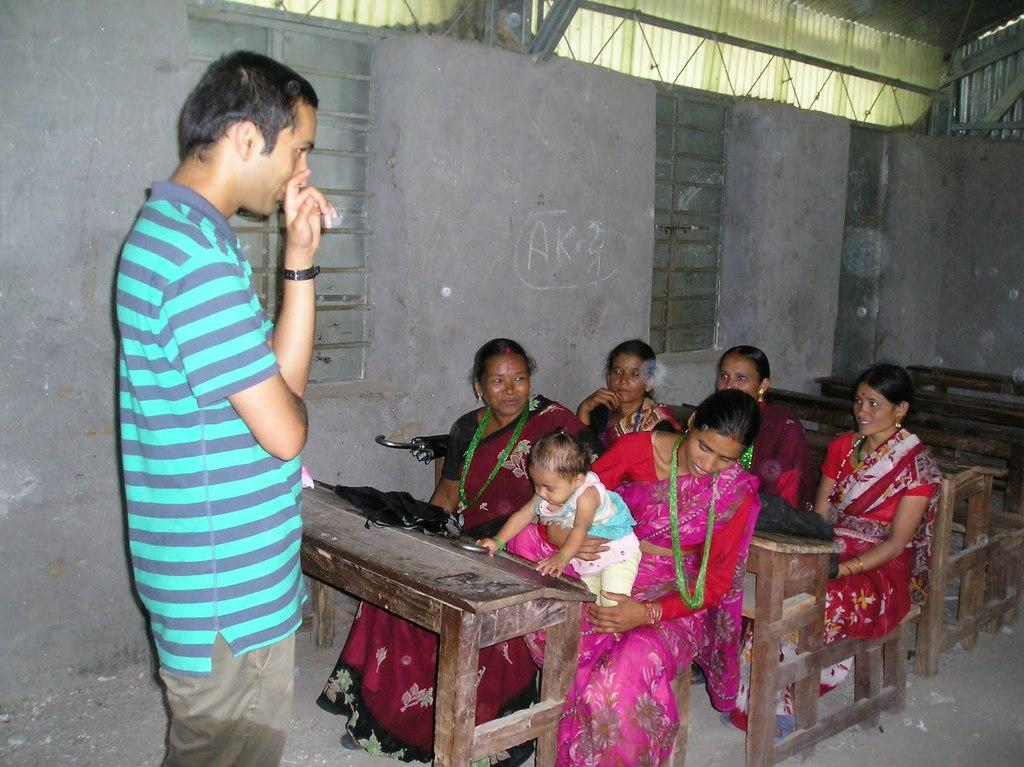What is the man in the image doing? The man is standing in the image and smiling. What are the women in the image doing? The women are sitting on a bench in the image and smiling. How many benches are visible in the image? There are empty benches in the image in addition to the one with the women sitting on it. What can be seen in the background of the image? There are windows and a wall visible in the image. Can you see a trail leading to the sea in the image? There is no trail or sea present in the image; it features a man standing and women sitting on a bench. Is there a stove visible in the image? There is no stove present in the image. 